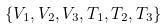Convert formula to latex. <formula><loc_0><loc_0><loc_500><loc_500>\{ { V } _ { 1 } , { V } _ { 2 } , { V } _ { 3 } , { T } _ { 1 } , { T } _ { 2 } , { T } _ { 3 } \}</formula> 